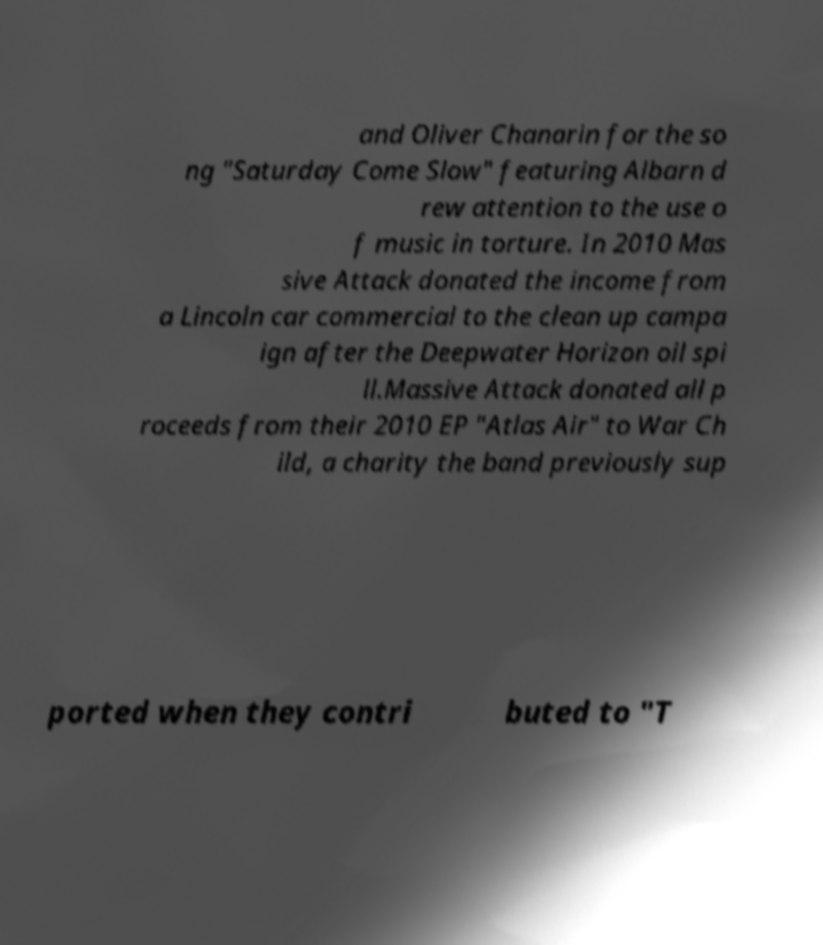I need the written content from this picture converted into text. Can you do that? and Oliver Chanarin for the so ng "Saturday Come Slow" featuring Albarn d rew attention to the use o f music in torture. In 2010 Mas sive Attack donated the income from a Lincoln car commercial to the clean up campa ign after the Deepwater Horizon oil spi ll.Massive Attack donated all p roceeds from their 2010 EP "Atlas Air" to War Ch ild, a charity the band previously sup ported when they contri buted to "T 